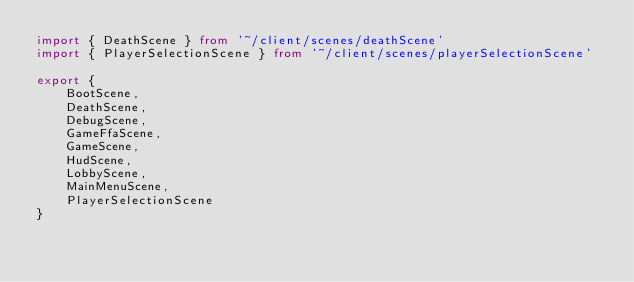Convert code to text. <code><loc_0><loc_0><loc_500><loc_500><_TypeScript_>import { DeathScene } from '~/client/scenes/deathScene'
import { PlayerSelectionScene } from '~/client/scenes/playerSelectionScene'

export {
    BootScene,
    DeathScene,
    DebugScene,
    GameFfaScene,
    GameScene,
    HudScene,
    LobbyScene,
    MainMenuScene,
    PlayerSelectionScene
}
</code> 